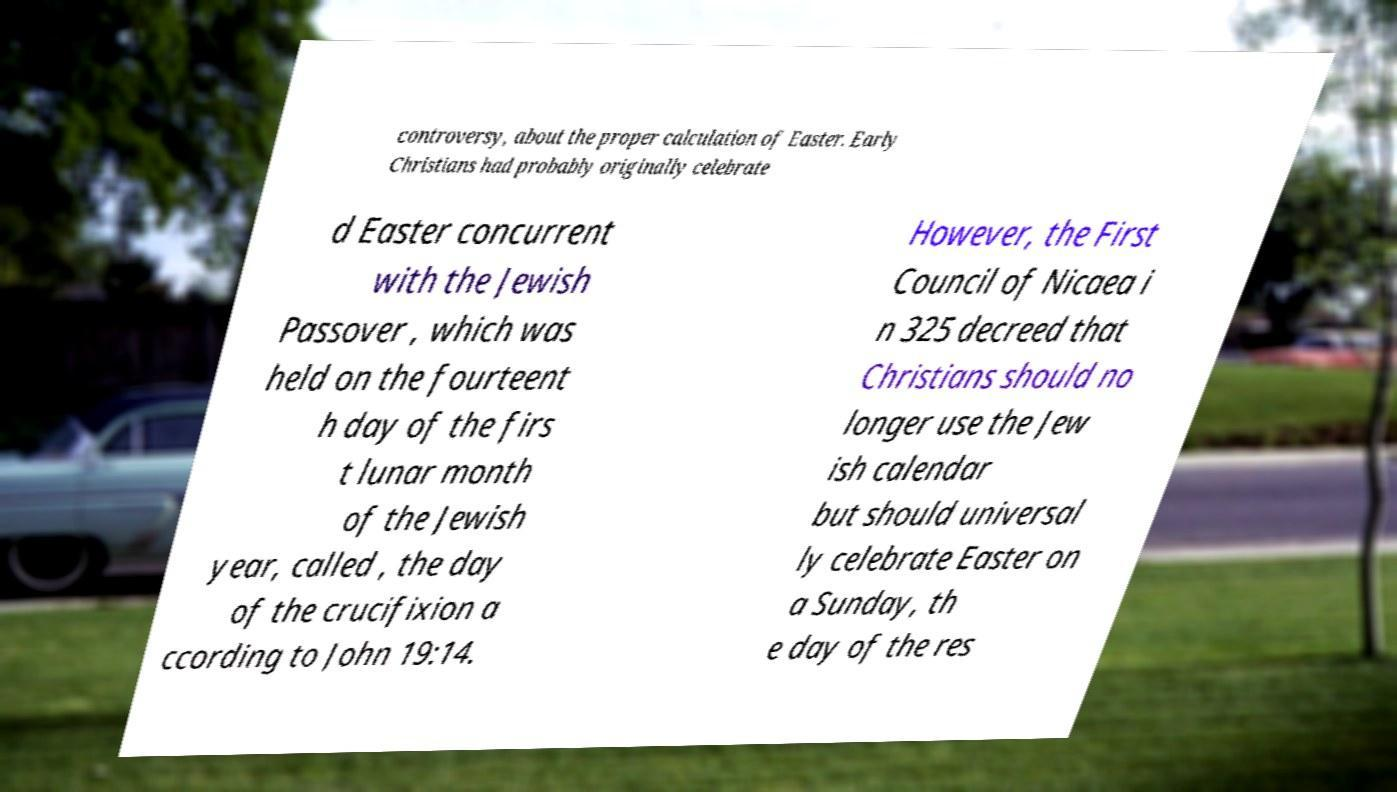Can you accurately transcribe the text from the provided image for me? controversy, about the proper calculation of Easter. Early Christians had probably originally celebrate d Easter concurrent with the Jewish Passover , which was held on the fourteent h day of the firs t lunar month of the Jewish year, called , the day of the crucifixion a ccording to John 19:14. However, the First Council of Nicaea i n 325 decreed that Christians should no longer use the Jew ish calendar but should universal ly celebrate Easter on a Sunday, th e day of the res 